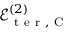Convert formula to latex. <formula><loc_0><loc_0><loc_500><loc_500>\mathcal { E } _ { t e r , C } ^ { ( 2 ) }</formula> 